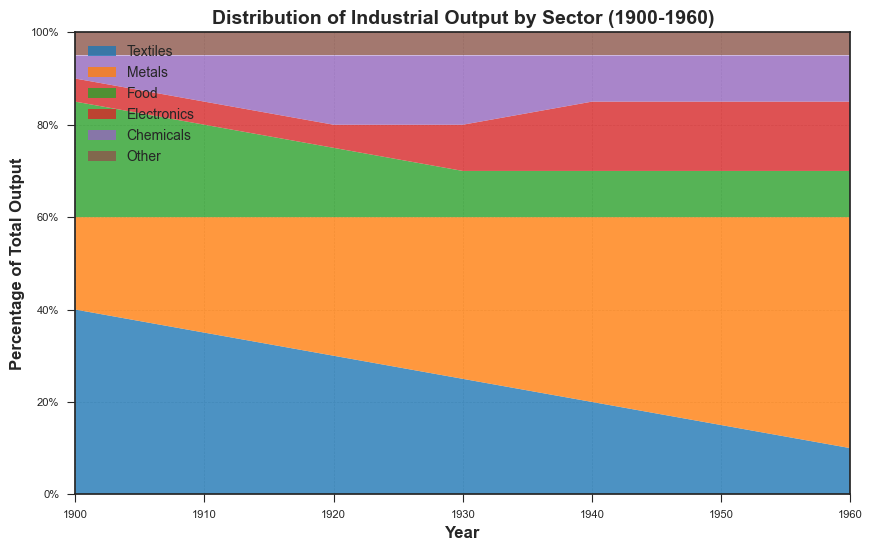1. What percentage of the total industrial output was contributed by the Food sector in 1910? Locate the year 1910 on the x-axis and find the area corresponding to the Food sector. The area for Food in 1910 shows 20%.
Answer: 20% 2. Comparing 1900 and 1960, which sector experienced the largest percentage decrease in its contribution to the industrial output? Review contributions from each sector in 1900 and 1960, then calculate the decrease for each. Textiles dropped from 40% to 10%, the largest decrease (30%).
Answer: Textiles 3. By how much did the Metals sector contribution increase from 1900 to 1950? Locate the percentages for the Metals sector in 1900 (20%) and 1950 (45%) and subtract the former from the latter: 45% - 20% = 25%.
Answer: 25% 4. Which sector showed the highest growth in percentage terms between 1900 and 1940? Examine the data for each sector between 1900 and 1940, calculating the difference. Metals rose from 20% to 40%, showing a 20% increase—the highest growth.
Answer: Metals 5. How did the contribution of the Electronics sector change from 1920 to 1960? Check the Electronics percentage in both years: it increased from 5% in 1920 to 15% in 1960, indicating a growth of 10%.
Answer: Increased by 10% 6. In what year did Textiles and Metals contribute the same percentage to the industrial output? Identify the year where the areas corresponding to Textiles and Metals sectors intersect. They both contribute 30% in 1920.
Answer: 1920 7. Which sector consistently maintained a 5% contribution across all years? Look for the sector whose area remains constant at 5% throughout the timeline. This is the "Other" sector.
Answer: Other 8. What was the combined contribution of Chemicals and Electronics sectors in 1940? Sum the contributions of both sectors for 1940: Electronics (15%) + Chemicals (10%) = 25%.
Answer: 25% 9. When did the Food sector's contribution fall to its lowest value, and what was that value? Identify the lowest point on the Food sector area. The lowest value for Food is 10%, which occurred in 1930 and persisted until 1960.
Answer: 1930, 10% 10. How much total percentage contribution did Textiles and Food sectors collectively lose from 1900 to 1940? Calculate the sum of declines for both sectors: Textiles (40% to 20%, a 20% decrease) and Food (25% to 10%, a 15% decrease), totaling 35%.
Answer: 35% 